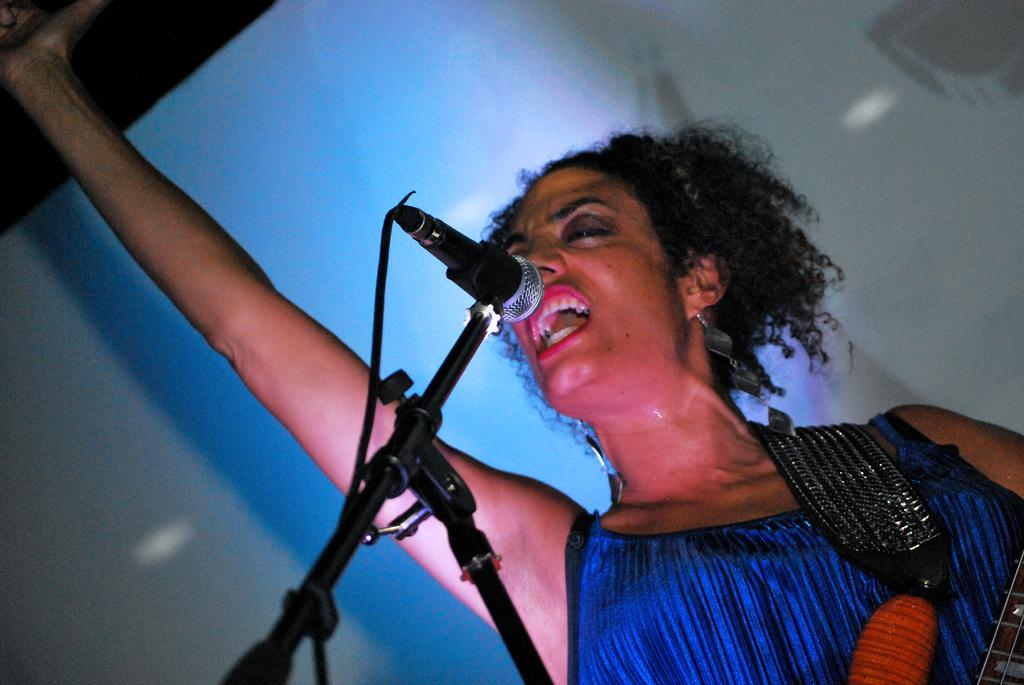Who is present in the image? There is a woman in the image. What object is visible in the image that is typically used for amplifying sound? There is a microphone in the image. Can you describe the background of the image? There is a white color object in the background of the image. What type of cork can be seen in the image? There is no cork present in the image. Is the woman in the image at a hospital? The image does not provide any information about the location or context of the woman, so it cannot be determined if she is at a hospital. 